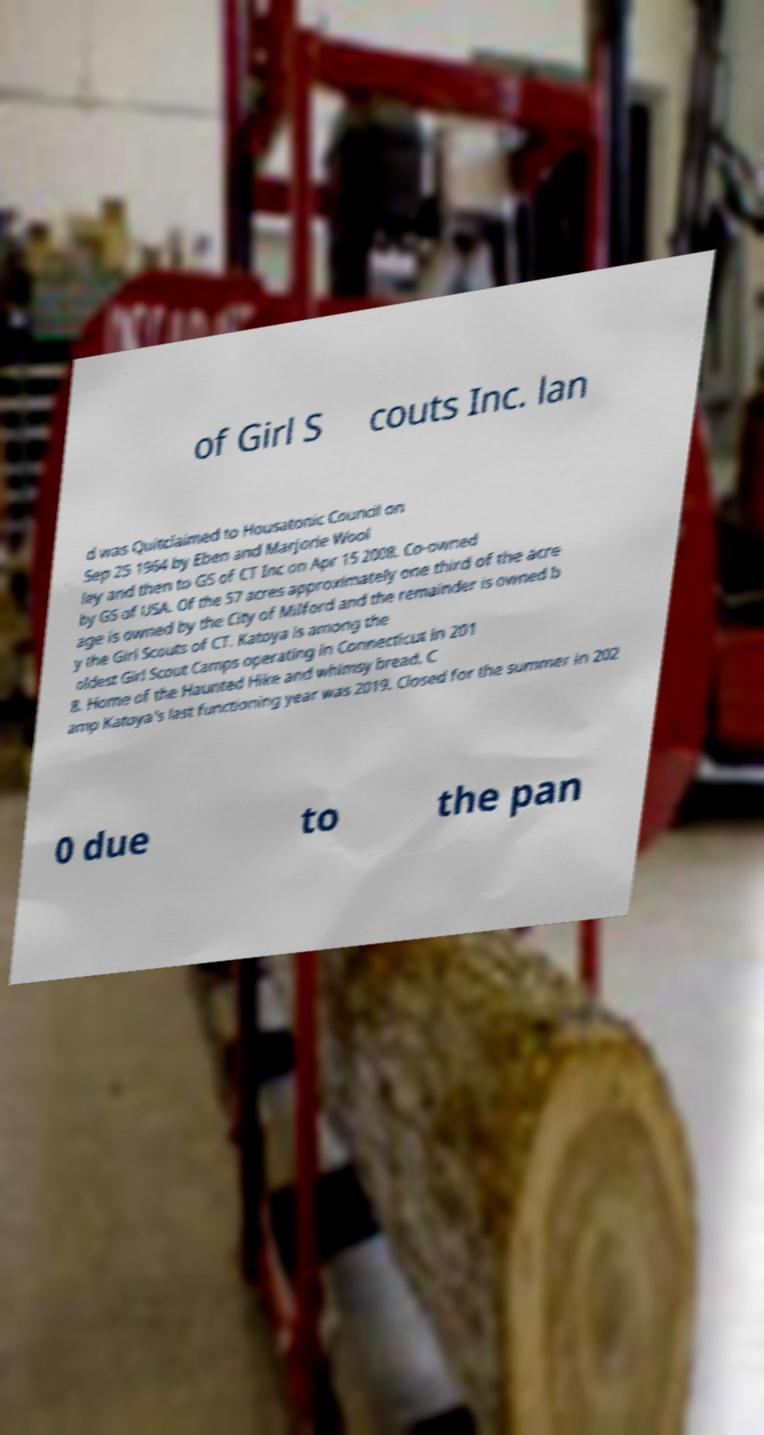What messages or text are displayed in this image? I need them in a readable, typed format. of Girl S couts Inc. lan d was Quitclaimed to Housatonic Council on Sep 25 1964 by Eben and Marjorie Wool ley and then to GS of CT Inc on Apr 15 2008. Co-owned by GS of USA. Of the 57 acres approximately one third of the acre age is owned by the City of Milford and the remainder is owned b y the Girl Scouts of CT. Katoya is among the oldest Girl Scout Camps operating in Connecticut in 201 8. Home of the Haunted Hike and whimsy bread. C amp Katoya's last functioning year was 2019. Closed for the summer in 202 0 due to the pan 